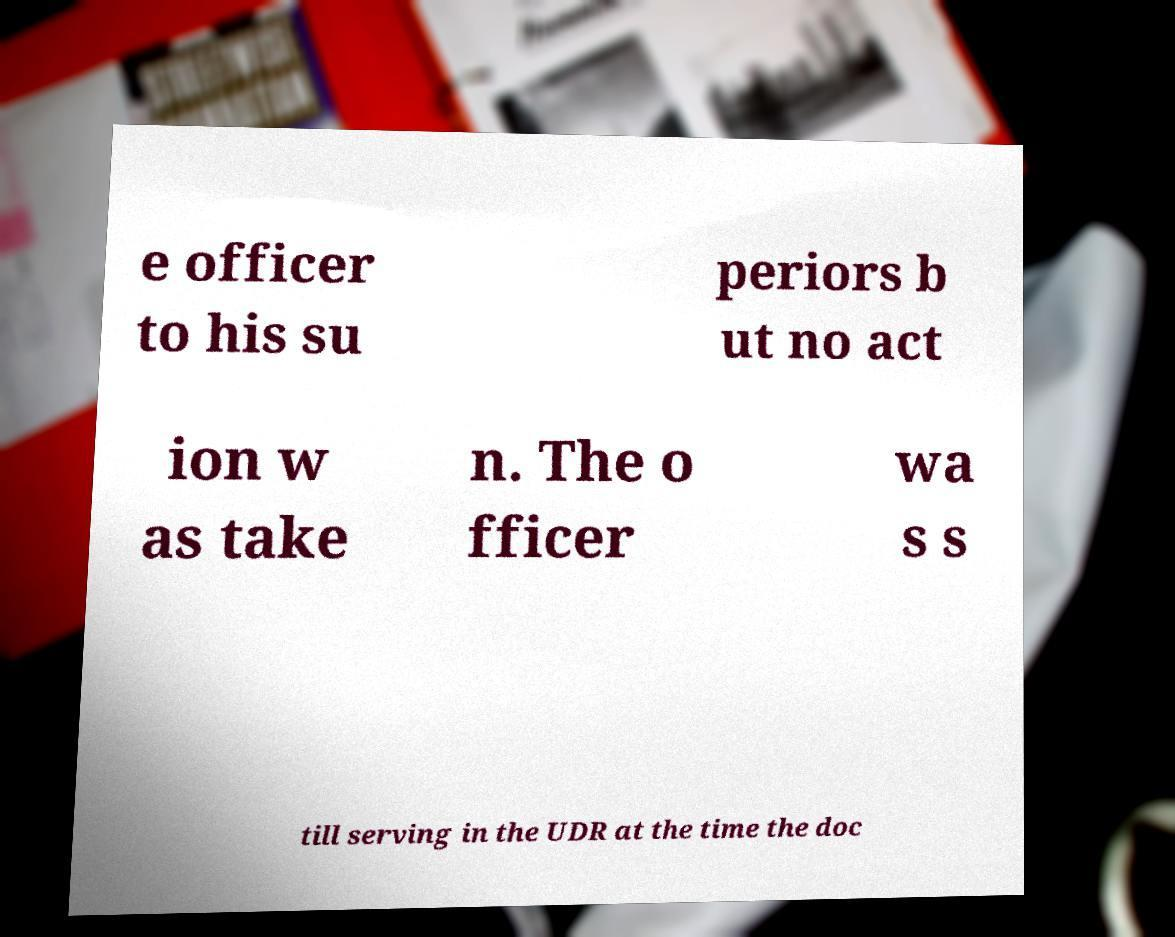Please read and relay the text visible in this image. What does it say? e officer to his su periors b ut no act ion w as take n. The o fficer wa s s till serving in the UDR at the time the doc 